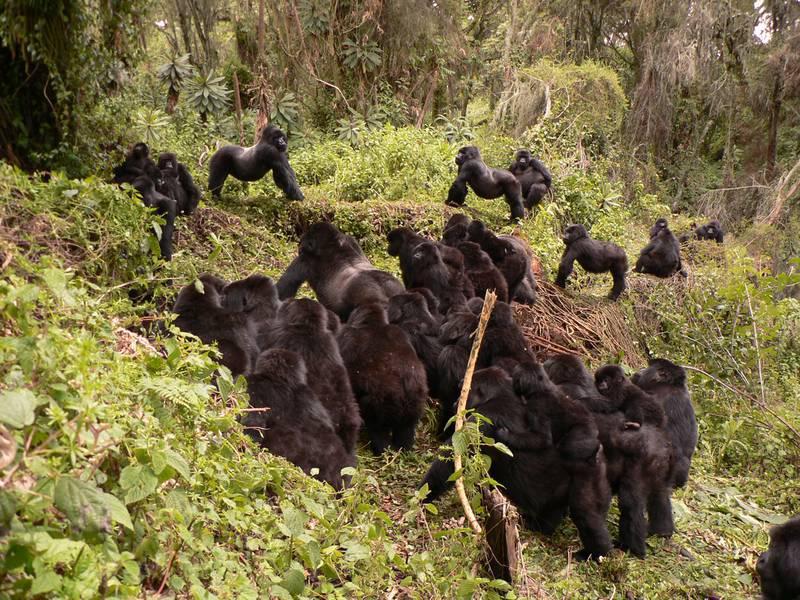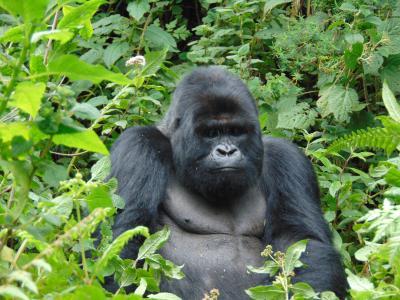The first image is the image on the left, the second image is the image on the right. Considering the images on both sides, is "There are no more than two animals in a grassy area in the image on the right." valid? Answer yes or no. Yes. The first image is the image on the left, the second image is the image on the right. For the images displayed, is the sentence "The right image contains at least three gorillas." factually correct? Answer yes or no. No. 